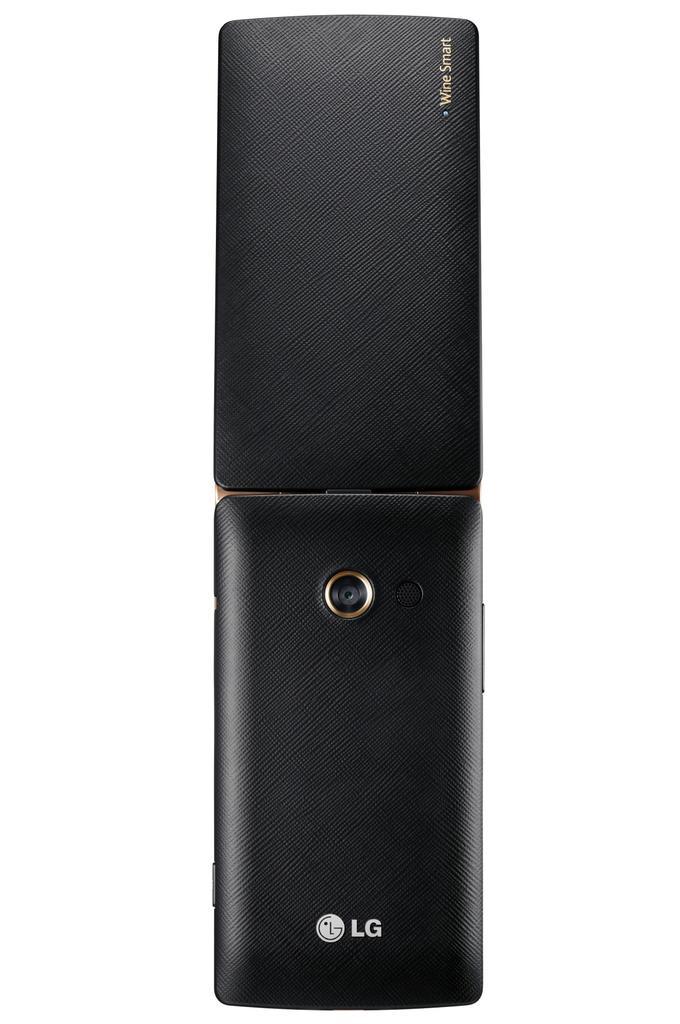Please provide a concise description of this image. In this image there is a LG phone. 